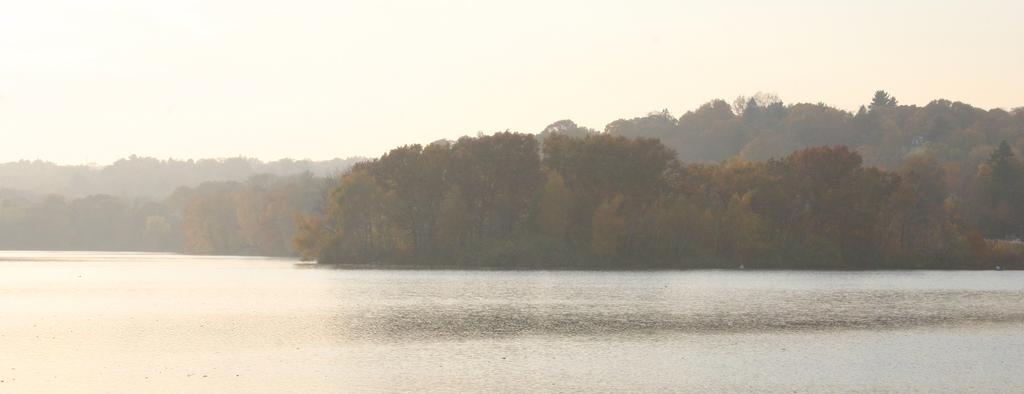What is the main feature in the foreground of the image? There is a river in the foreground of the image. What can be seen in the background of the image? There are trees and the sky visible in the background of the image. What type of scent can be detected coming from the kettle in the image? There is no kettle present in the image, so it is not possible to determine any scent. 